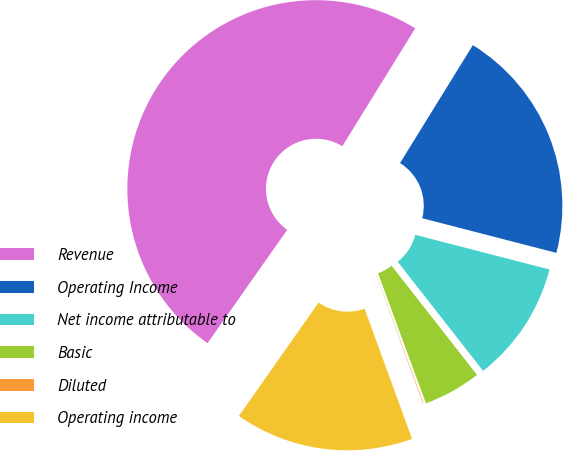Convert chart to OTSL. <chart><loc_0><loc_0><loc_500><loc_500><pie_chart><fcel>Revenue<fcel>Operating Income<fcel>Net income attributable to<fcel>Basic<fcel>Diluted<fcel>Operating income<nl><fcel>49.06%<fcel>20.22%<fcel>10.41%<fcel>4.95%<fcel>0.05%<fcel>15.32%<nl></chart> 